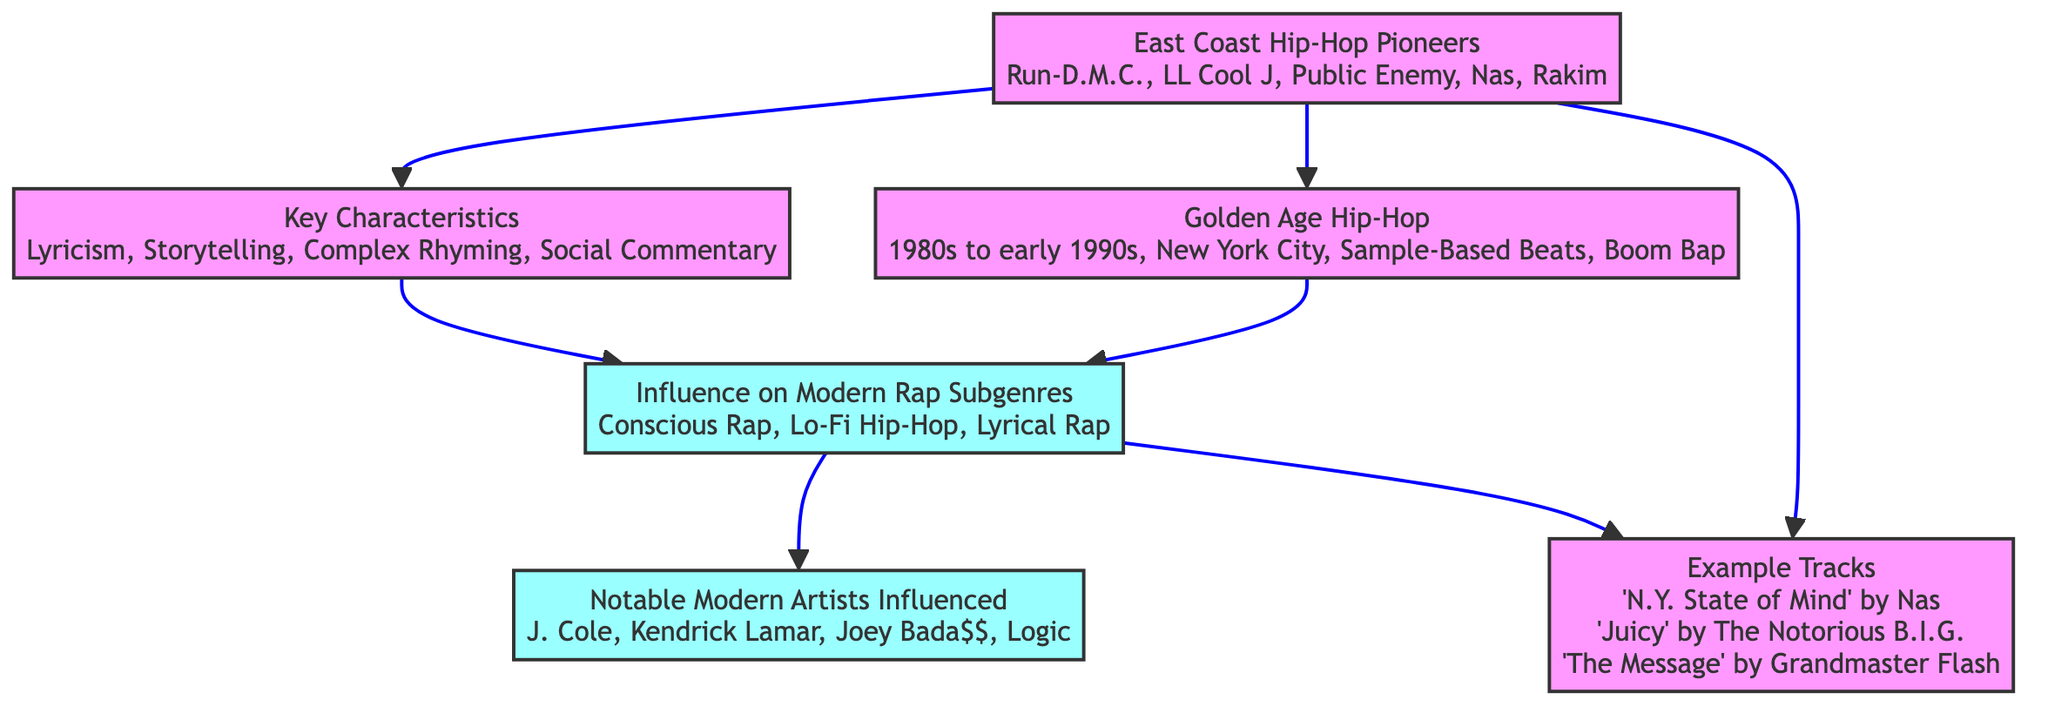What are the key characteristics of East Coast hip-hop? The "Key Characteristics" node directly lists Lyricism, Storytelling, Complex Rhyming, and Social Commentary as essential traits.
Answer: Lyricism, Storytelling, Complex Rhyming, Social Commentary How many East Coast hip-hop pioneers are mentioned? The "East Coast Hip-Hop Pioneers" node includes five names: Run-D.M.C., LL Cool J, Public Enemy, Nas, and Rakim. Therefore, the count is five.
Answer: 5 Which genre is influenced by both East Coast hip-hop pioneers and the golden age hip-hop? The "Influence on Modern Rap Subgenres" node connects from both the "Key Characteristics" and "Golden Age Hip-Hop" nodes, indicating that characteristics and elements from both influence genres such as Conscious Rap, Lo-Fi Hip-Hop, and Lyrical Rap.
Answer: Conscious Rap, Lo-Fi Hip-Hop, Lyrical Rap Who is a notable modern artist influenced by East Coast hip-hop? The "Notable Modern Artists Influenced" node lists artists like J. Cole, Kendrick Lamar, Joey Bada$$, and Logic, indicating these artists have been influenced by East Coast hip-hop.
Answer: J. Cole, Kendrick Lamar, Joey Bada$$, Logic What is the relationship between East Coast hip-hop pioneers and example tracks? The "East Coast Hip-Hop Pioneers" node connects directly to the "Example Tracks" node, showing that those pioneers contributed to the creation of iconic tracks such as "N.Y. State of Mind" by Nas, "Juicy" by The Notorious B.I.G., and "The Message" by Grandmaster Flash.
Answer: Direct connection Which decade is categorized as Golden Age hip-hop? The "Golden Age Hip-Hop" node specifies the time period as the 1980s to early 1990s, indicating the defining years of this influential era.
Answer: 1980s to early 1990s How many modern rap subgenres are identified? The "Influence on Modern Rap Subgenres" node identifies three subgenres: Conscious Rap, Lo-Fi Hip-Hop, and Lyrical Rap, yielding a total of three distinct subgenres.
Answer: 3 Which artists influenced by East Coast hip-hop have West Coast roots? The "Notable Modern Artists Influenced" node includes Kendrick Lamar, identified as having West Coast roots yet still being influenced by East Coast hip-hop’s characteristics.
Answer: Kendrick Lamar 